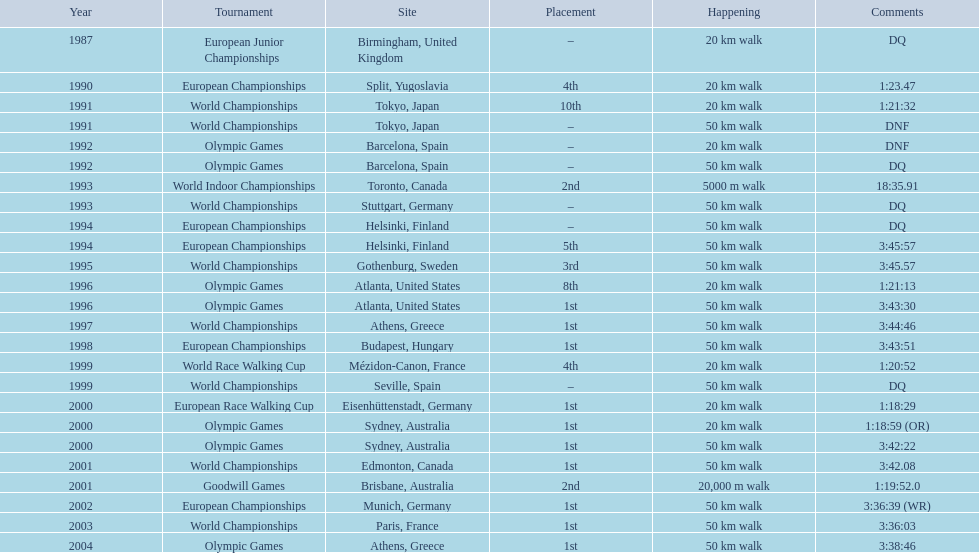How many events were at least 50 km? 17. Write the full table. {'header': ['Year', 'Tournament', 'Site', 'Placement', 'Happening', 'Comments'], 'rows': [['1987', 'European Junior Championships', 'Birmingham, United Kingdom', '–', '20\xa0km walk', 'DQ'], ['1990', 'European Championships', 'Split, Yugoslavia', '4th', '20\xa0km walk', '1:23.47'], ['1991', 'World Championships', 'Tokyo, Japan', '10th', '20\xa0km walk', '1:21:32'], ['1991', 'World Championships', 'Tokyo, Japan', '–', '50\xa0km walk', 'DNF'], ['1992', 'Olympic Games', 'Barcelona, Spain', '–', '20\xa0km walk', 'DNF'], ['1992', 'Olympic Games', 'Barcelona, Spain', '–', '50\xa0km walk', 'DQ'], ['1993', 'World Indoor Championships', 'Toronto, Canada', '2nd', '5000 m walk', '18:35.91'], ['1993', 'World Championships', 'Stuttgart, Germany', '–', '50\xa0km walk', 'DQ'], ['1994', 'European Championships', 'Helsinki, Finland', '–', '50\xa0km walk', 'DQ'], ['1994', 'European Championships', 'Helsinki, Finland', '5th', '50\xa0km walk', '3:45:57'], ['1995', 'World Championships', 'Gothenburg, Sweden', '3rd', '50\xa0km walk', '3:45.57'], ['1996', 'Olympic Games', 'Atlanta, United States', '8th', '20\xa0km walk', '1:21:13'], ['1996', 'Olympic Games', 'Atlanta, United States', '1st', '50\xa0km walk', '3:43:30'], ['1997', 'World Championships', 'Athens, Greece', '1st', '50\xa0km walk', '3:44:46'], ['1998', 'European Championships', 'Budapest, Hungary', '1st', '50\xa0km walk', '3:43:51'], ['1999', 'World Race Walking Cup', 'Mézidon-Canon, France', '4th', '20\xa0km walk', '1:20:52'], ['1999', 'World Championships', 'Seville, Spain', '–', '50\xa0km walk', 'DQ'], ['2000', 'European Race Walking Cup', 'Eisenhüttenstadt, Germany', '1st', '20\xa0km walk', '1:18:29'], ['2000', 'Olympic Games', 'Sydney, Australia', '1st', '20\xa0km walk', '1:18:59 (OR)'], ['2000', 'Olympic Games', 'Sydney, Australia', '1st', '50\xa0km walk', '3:42:22'], ['2001', 'World Championships', 'Edmonton, Canada', '1st', '50\xa0km walk', '3:42.08'], ['2001', 'Goodwill Games', 'Brisbane, Australia', '2nd', '20,000 m walk', '1:19:52.0'], ['2002', 'European Championships', 'Munich, Germany', '1st', '50\xa0km walk', '3:36:39 (WR)'], ['2003', 'World Championships', 'Paris, France', '1st', '50\xa0km walk', '3:36:03'], ['2004', 'Olympic Games', 'Athens, Greece', '1st', '50\xa0km walk', '3:38:46']]} 